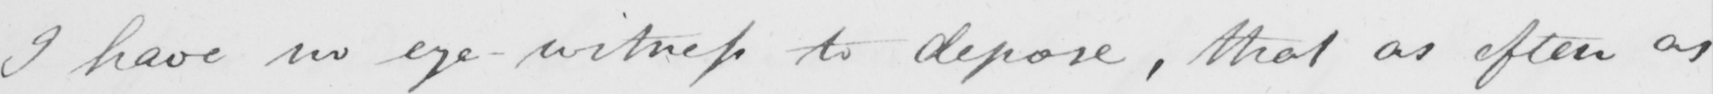Please transcribe the handwritten text in this image. I have no eye-witness to depose , that as often as 